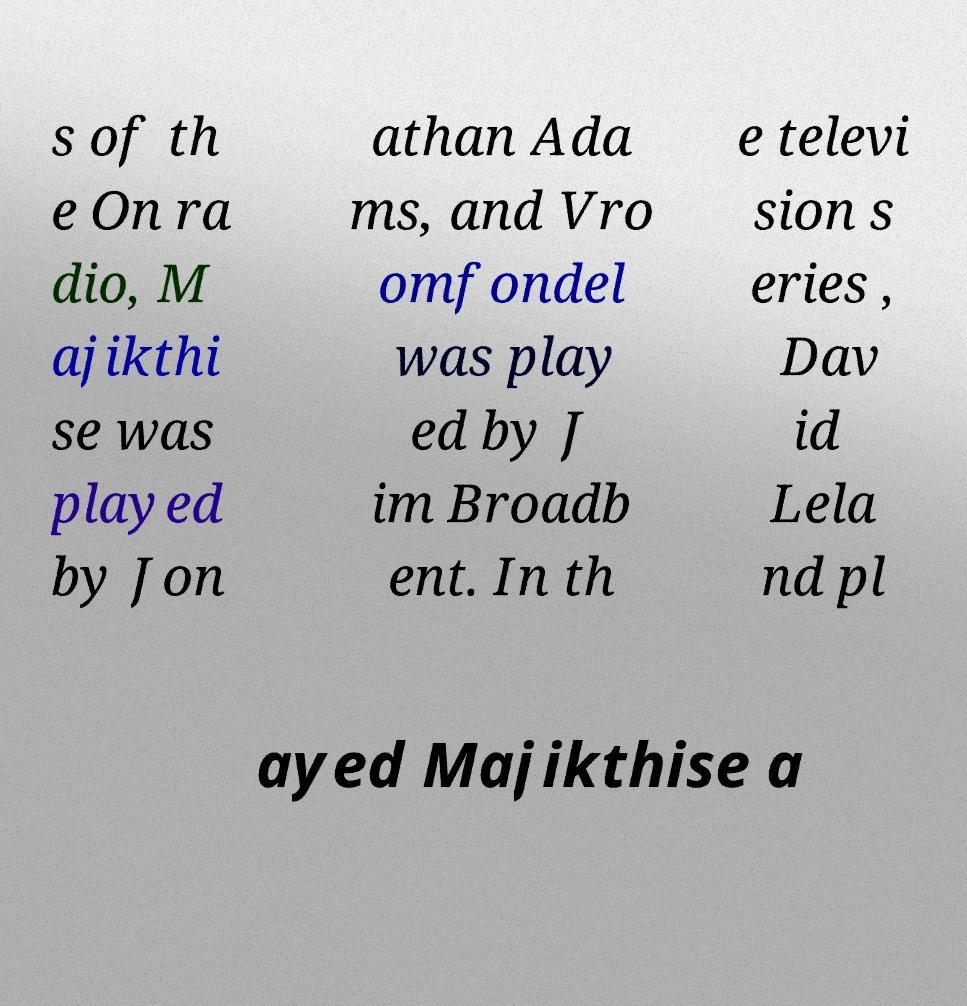I need the written content from this picture converted into text. Can you do that? s of th e On ra dio, M ajikthi se was played by Jon athan Ada ms, and Vro omfondel was play ed by J im Broadb ent. In th e televi sion s eries , Dav id Lela nd pl ayed Majikthise a 